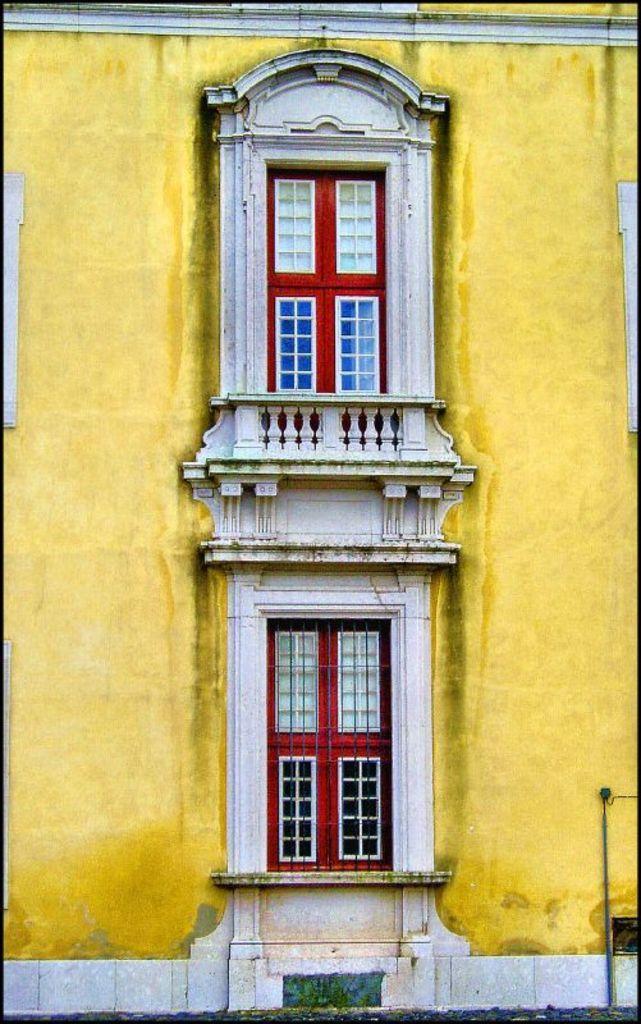Could you give a brief overview of what you see in this image? In this image I see a wall, which is of yellow in color and there are 2 windows on it. 